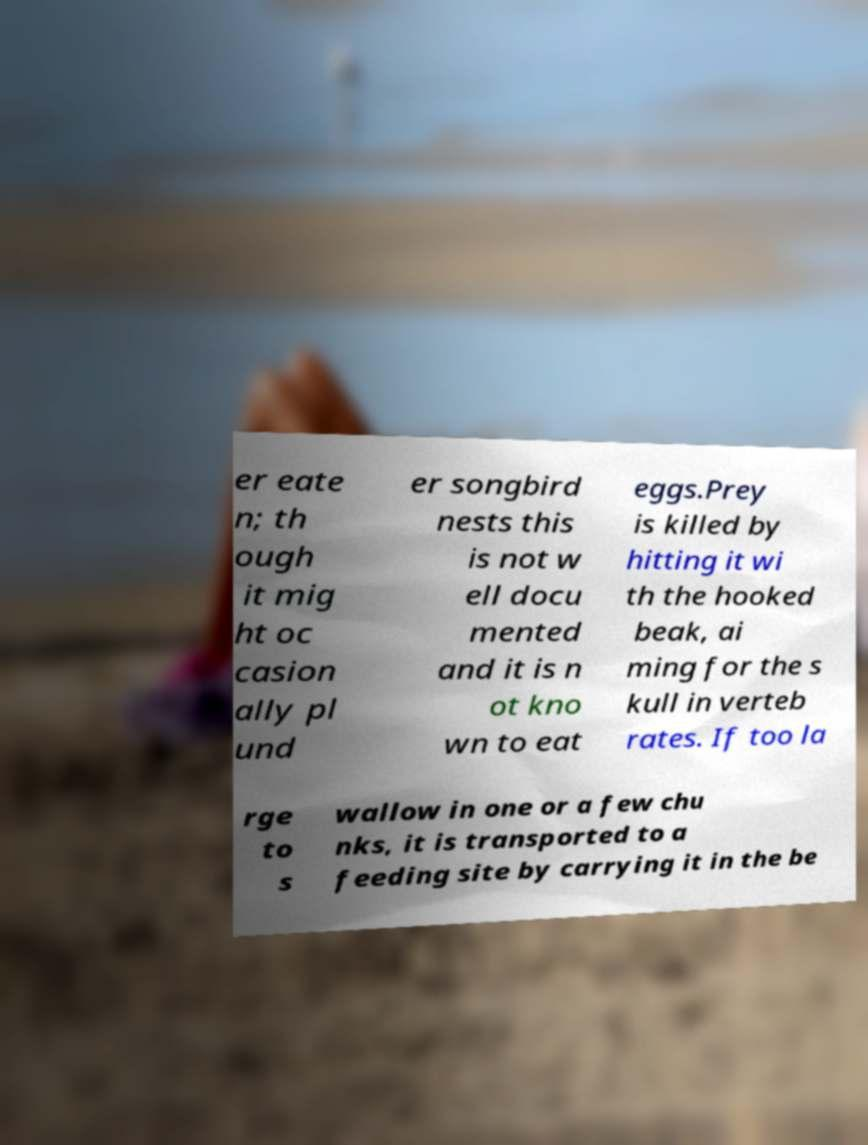I need the written content from this picture converted into text. Can you do that? er eate n; th ough it mig ht oc casion ally pl und er songbird nests this is not w ell docu mented and it is n ot kno wn to eat eggs.Prey is killed by hitting it wi th the hooked beak, ai ming for the s kull in verteb rates. If too la rge to s wallow in one or a few chu nks, it is transported to a feeding site by carrying it in the be 